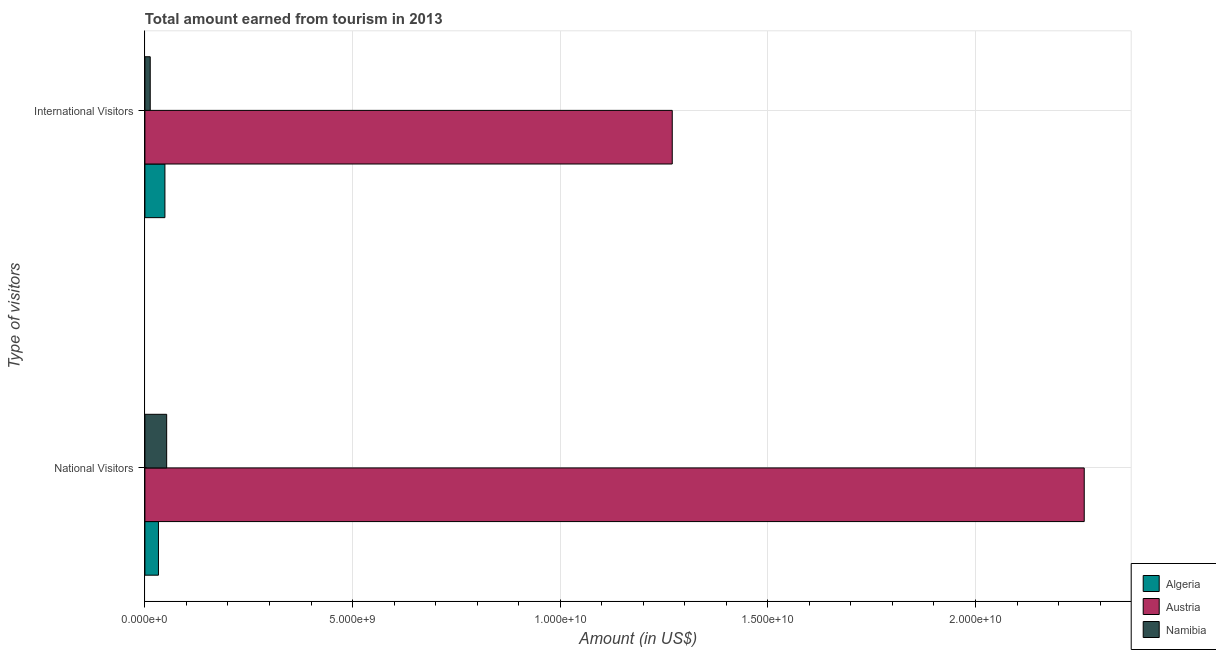Are the number of bars per tick equal to the number of legend labels?
Offer a terse response. Yes. How many bars are there on the 2nd tick from the bottom?
Ensure brevity in your answer.  3. What is the label of the 1st group of bars from the top?
Provide a short and direct response. International Visitors. What is the amount earned from national visitors in Algeria?
Your answer should be compact. 3.26e+08. Across all countries, what is the maximum amount earned from international visitors?
Ensure brevity in your answer.  1.27e+1. Across all countries, what is the minimum amount earned from international visitors?
Your answer should be very brief. 1.28e+08. In which country was the amount earned from national visitors minimum?
Your answer should be compact. Algeria. What is the total amount earned from international visitors in the graph?
Ensure brevity in your answer.  1.33e+1. What is the difference between the amount earned from international visitors in Namibia and that in Algeria?
Your answer should be very brief. -3.54e+08. What is the difference between the amount earned from national visitors in Algeria and the amount earned from international visitors in Namibia?
Your response must be concise. 1.98e+08. What is the average amount earned from national visitors per country?
Keep it short and to the point. 7.82e+09. What is the difference between the amount earned from national visitors and amount earned from international visitors in Algeria?
Give a very brief answer. -1.56e+08. In how many countries, is the amount earned from national visitors greater than 10000000000 US$?
Your answer should be very brief. 1. What is the ratio of the amount earned from national visitors in Algeria to that in Namibia?
Ensure brevity in your answer.  0.62. Is the amount earned from national visitors in Austria less than that in Algeria?
Ensure brevity in your answer.  No. What does the 2nd bar from the top in International Visitors represents?
Your answer should be very brief. Austria. What does the 3rd bar from the bottom in International Visitors represents?
Make the answer very short. Namibia. What is the difference between two consecutive major ticks on the X-axis?
Your answer should be compact. 5.00e+09. Does the graph contain any zero values?
Your response must be concise. No. How many legend labels are there?
Keep it short and to the point. 3. What is the title of the graph?
Offer a terse response. Total amount earned from tourism in 2013. What is the label or title of the Y-axis?
Provide a succinct answer. Type of visitors. What is the Amount (in US$) in Algeria in National Visitors?
Make the answer very short. 3.26e+08. What is the Amount (in US$) of Austria in National Visitors?
Give a very brief answer. 2.26e+1. What is the Amount (in US$) in Namibia in National Visitors?
Your response must be concise. 5.24e+08. What is the Amount (in US$) of Algeria in International Visitors?
Provide a succinct answer. 4.82e+08. What is the Amount (in US$) of Austria in International Visitors?
Give a very brief answer. 1.27e+1. What is the Amount (in US$) of Namibia in International Visitors?
Keep it short and to the point. 1.28e+08. Across all Type of visitors, what is the maximum Amount (in US$) of Algeria?
Provide a succinct answer. 4.82e+08. Across all Type of visitors, what is the maximum Amount (in US$) in Austria?
Your answer should be compact. 2.26e+1. Across all Type of visitors, what is the maximum Amount (in US$) in Namibia?
Ensure brevity in your answer.  5.24e+08. Across all Type of visitors, what is the minimum Amount (in US$) in Algeria?
Your answer should be very brief. 3.26e+08. Across all Type of visitors, what is the minimum Amount (in US$) of Austria?
Provide a short and direct response. 1.27e+1. Across all Type of visitors, what is the minimum Amount (in US$) of Namibia?
Your response must be concise. 1.28e+08. What is the total Amount (in US$) in Algeria in the graph?
Keep it short and to the point. 8.08e+08. What is the total Amount (in US$) in Austria in the graph?
Keep it short and to the point. 3.53e+1. What is the total Amount (in US$) of Namibia in the graph?
Offer a terse response. 6.52e+08. What is the difference between the Amount (in US$) of Algeria in National Visitors and that in International Visitors?
Your response must be concise. -1.56e+08. What is the difference between the Amount (in US$) of Austria in National Visitors and that in International Visitors?
Your answer should be compact. 9.92e+09. What is the difference between the Amount (in US$) in Namibia in National Visitors and that in International Visitors?
Provide a short and direct response. 3.96e+08. What is the difference between the Amount (in US$) in Algeria in National Visitors and the Amount (in US$) in Austria in International Visitors?
Ensure brevity in your answer.  -1.24e+1. What is the difference between the Amount (in US$) in Algeria in National Visitors and the Amount (in US$) in Namibia in International Visitors?
Provide a succinct answer. 1.98e+08. What is the difference between the Amount (in US$) of Austria in National Visitors and the Amount (in US$) of Namibia in International Visitors?
Keep it short and to the point. 2.25e+1. What is the average Amount (in US$) in Algeria per Type of visitors?
Make the answer very short. 4.04e+08. What is the average Amount (in US$) of Austria per Type of visitors?
Your answer should be compact. 1.77e+1. What is the average Amount (in US$) in Namibia per Type of visitors?
Make the answer very short. 3.26e+08. What is the difference between the Amount (in US$) in Algeria and Amount (in US$) in Austria in National Visitors?
Provide a short and direct response. -2.23e+1. What is the difference between the Amount (in US$) of Algeria and Amount (in US$) of Namibia in National Visitors?
Make the answer very short. -1.98e+08. What is the difference between the Amount (in US$) of Austria and Amount (in US$) of Namibia in National Visitors?
Give a very brief answer. 2.21e+1. What is the difference between the Amount (in US$) of Algeria and Amount (in US$) of Austria in International Visitors?
Offer a terse response. -1.22e+1. What is the difference between the Amount (in US$) of Algeria and Amount (in US$) of Namibia in International Visitors?
Your response must be concise. 3.54e+08. What is the difference between the Amount (in US$) in Austria and Amount (in US$) in Namibia in International Visitors?
Ensure brevity in your answer.  1.26e+1. What is the ratio of the Amount (in US$) in Algeria in National Visitors to that in International Visitors?
Your response must be concise. 0.68. What is the ratio of the Amount (in US$) in Austria in National Visitors to that in International Visitors?
Ensure brevity in your answer.  1.78. What is the ratio of the Amount (in US$) of Namibia in National Visitors to that in International Visitors?
Offer a terse response. 4.09. What is the difference between the highest and the second highest Amount (in US$) in Algeria?
Provide a succinct answer. 1.56e+08. What is the difference between the highest and the second highest Amount (in US$) in Austria?
Ensure brevity in your answer.  9.92e+09. What is the difference between the highest and the second highest Amount (in US$) in Namibia?
Ensure brevity in your answer.  3.96e+08. What is the difference between the highest and the lowest Amount (in US$) in Algeria?
Give a very brief answer. 1.56e+08. What is the difference between the highest and the lowest Amount (in US$) of Austria?
Your response must be concise. 9.92e+09. What is the difference between the highest and the lowest Amount (in US$) of Namibia?
Your answer should be very brief. 3.96e+08. 